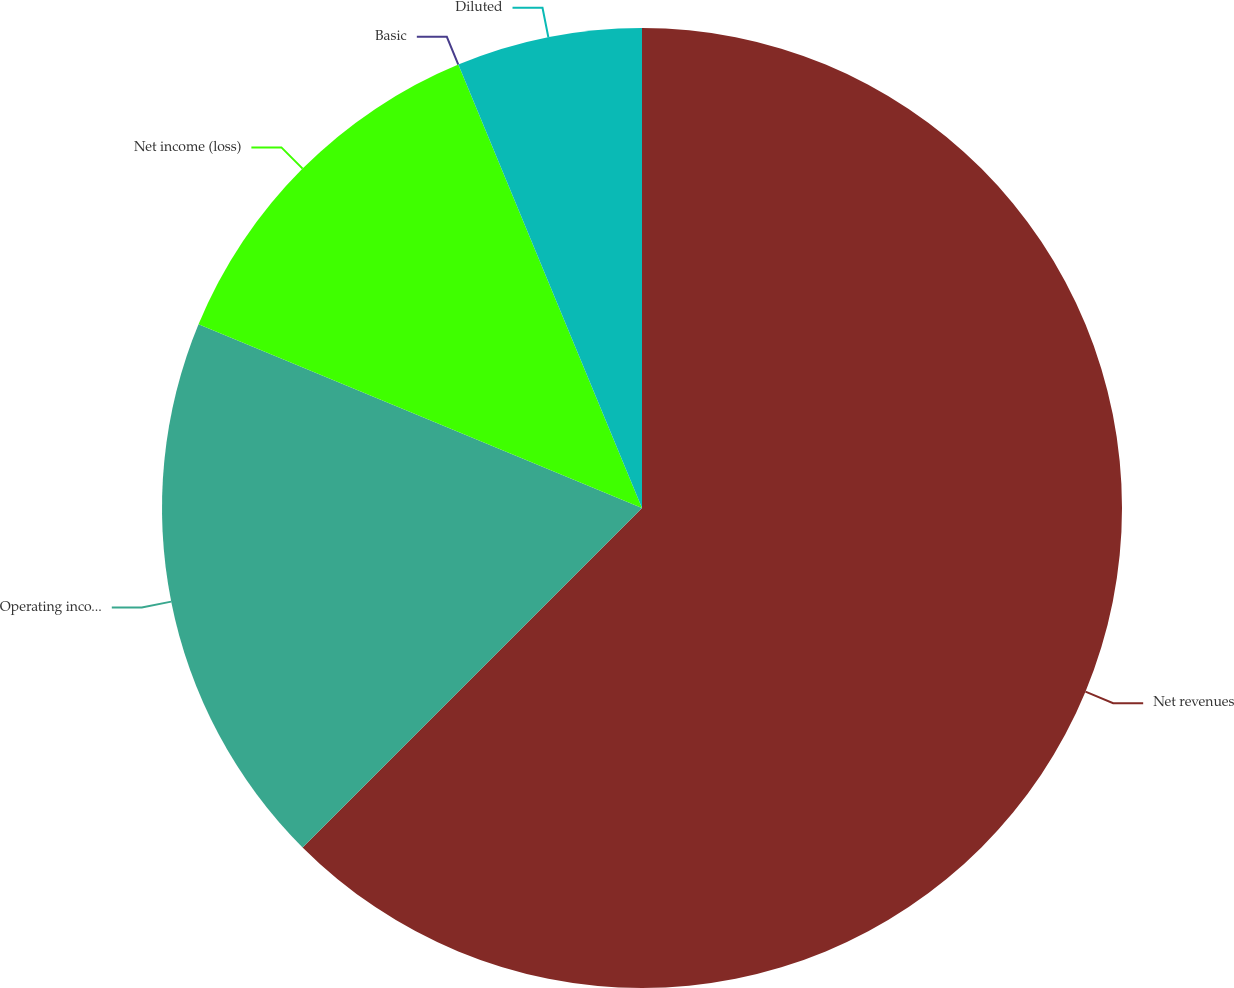Convert chart to OTSL. <chart><loc_0><loc_0><loc_500><loc_500><pie_chart><fcel>Net revenues<fcel>Operating income (loss)<fcel>Net income (loss)<fcel>Basic<fcel>Diluted<nl><fcel>62.5%<fcel>18.75%<fcel>12.5%<fcel>0.0%<fcel>6.25%<nl></chart> 